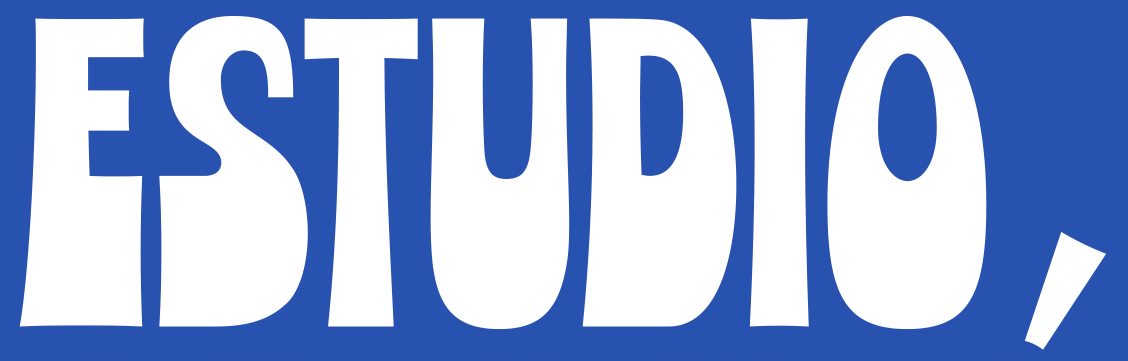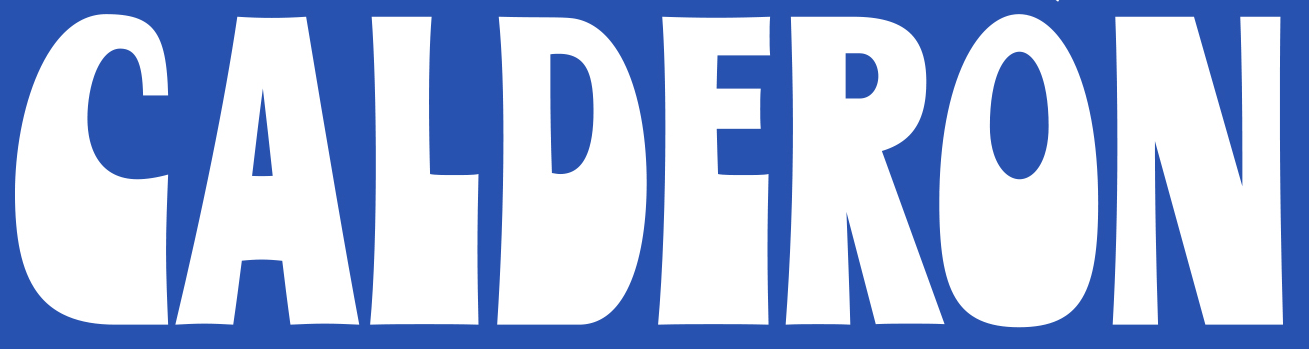What words can you see in these images in sequence, separated by a semicolon? ESTUDIO,; CALDERON 